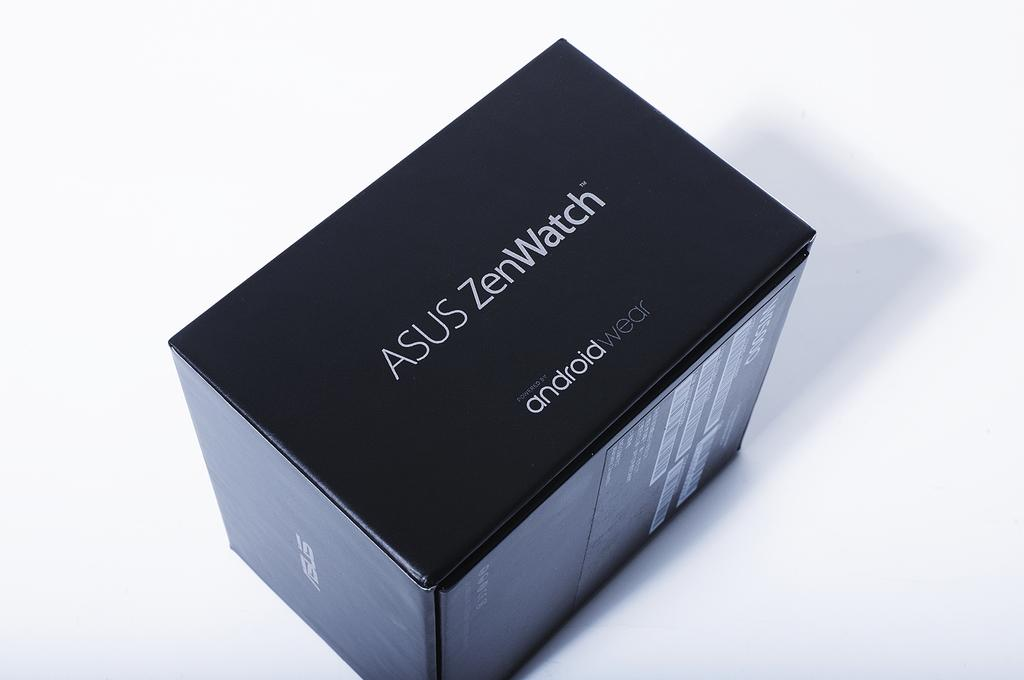<image>
Write a terse but informative summary of the picture. A box with an ASUS ZenWatch powered by android wear 